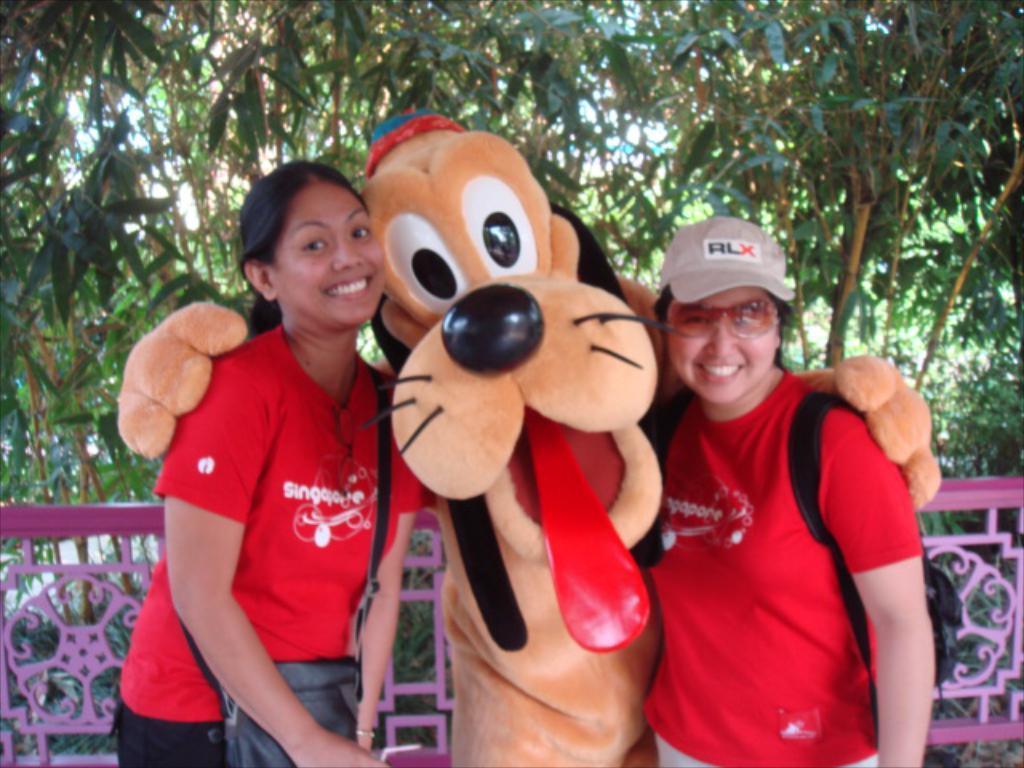Please provide a concise description of this image. In the center of the image there are two ladies. There is a depiction of a cartoon. In the background of the image there are trees. There is railing. 